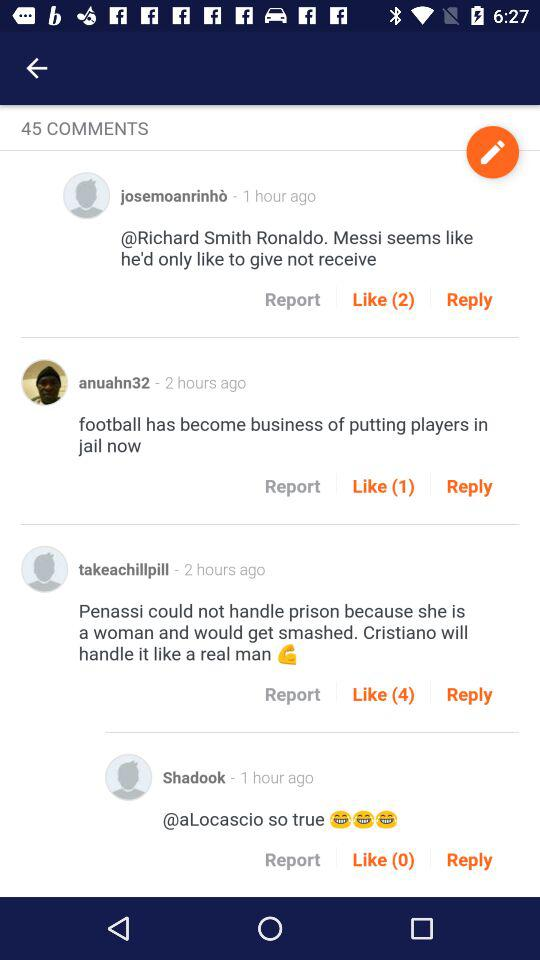How many likes are there for the comment by "takeachillpill"? There are 4 likes for the comment by "takeachillpill". 